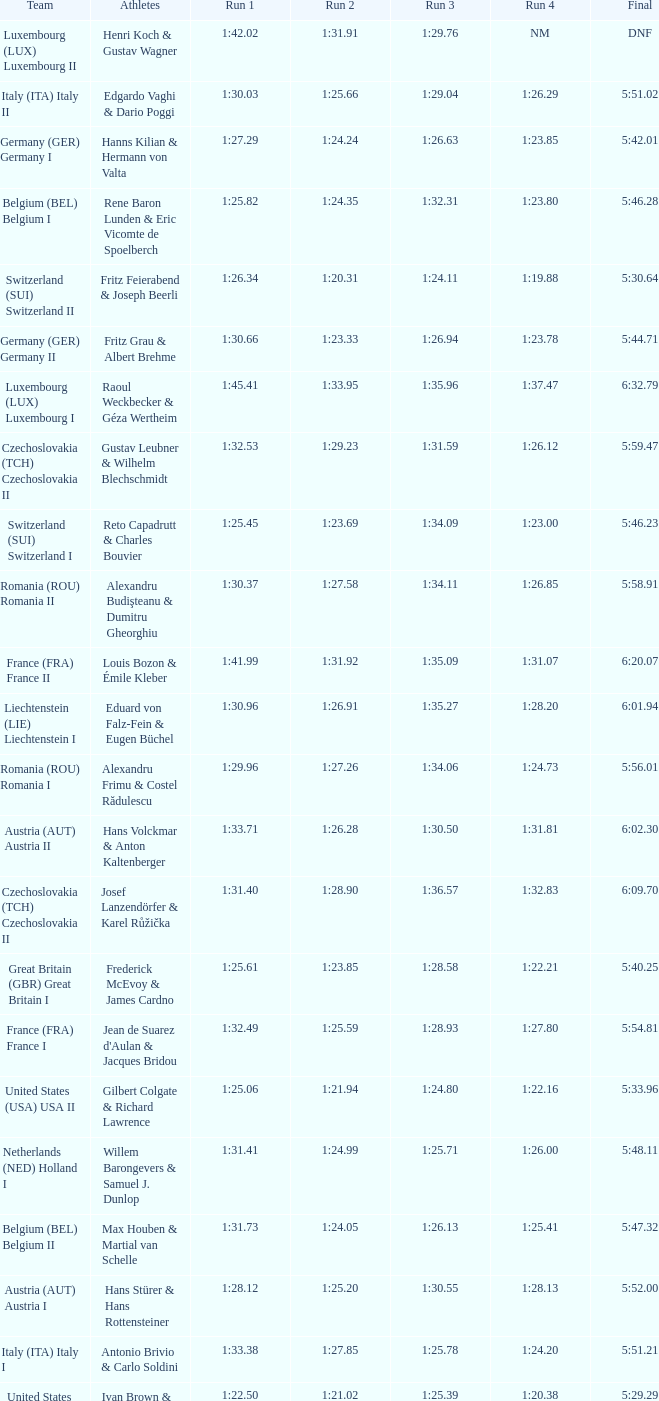Which Run 4 has a Run 3 of 1:26.63? 1:23.85. Write the full table. {'header': ['Team', 'Athletes', 'Run 1', 'Run 2', 'Run 3', 'Run 4', 'Final'], 'rows': [['Luxembourg (LUX) Luxembourg II', 'Henri Koch & Gustav Wagner', '1:42.02', '1:31.91', '1:29.76', 'NM', 'DNF'], ['Italy (ITA) Italy II', 'Edgardo Vaghi & Dario Poggi', '1:30.03', '1:25.66', '1:29.04', '1:26.29', '5:51.02'], ['Germany (GER) Germany I', 'Hanns Kilian & Hermann von Valta', '1:27.29', '1:24.24', '1:26.63', '1:23.85', '5:42.01'], ['Belgium (BEL) Belgium I', 'Rene Baron Lunden & Eric Vicomte de Spoelberch', '1:25.82', '1:24.35', '1:32.31', '1:23.80', '5:46.28'], ['Switzerland (SUI) Switzerland II', 'Fritz Feierabend & Joseph Beerli', '1:26.34', '1:20.31', '1:24.11', '1:19.88', '5:30.64'], ['Germany (GER) Germany II', 'Fritz Grau & Albert Brehme', '1:30.66', '1:23.33', '1:26.94', '1:23.78', '5:44.71'], ['Luxembourg (LUX) Luxembourg I', 'Raoul Weckbecker & Géza Wertheim', '1:45.41', '1:33.95', '1:35.96', '1:37.47', '6:32.79'], ['Czechoslovakia (TCH) Czechoslovakia II', 'Gustav Leubner & Wilhelm Blechschmidt', '1:32.53', '1:29.23', '1:31.59', '1:26.12', '5:59.47'], ['Switzerland (SUI) Switzerland I', 'Reto Capadrutt & Charles Bouvier', '1:25.45', '1:23.69', '1:34.09', '1:23.00', '5:46.23'], ['Romania (ROU) Romania II', 'Alexandru Budişteanu & Dumitru Gheorghiu', '1:30.37', '1:27.58', '1:34.11', '1:26.85', '5:58.91'], ['France (FRA) France II', 'Louis Bozon & Émile Kleber', '1:41.99', '1:31.92', '1:35.09', '1:31.07', '6:20.07'], ['Liechtenstein (LIE) Liechtenstein I', 'Eduard von Falz-Fein & Eugen Büchel', '1:30.96', '1:26.91', '1:35.27', '1:28.20', '6:01.94'], ['Romania (ROU) Romania I', 'Alexandru Frimu & Costel Rădulescu', '1:29.96', '1:27.26', '1:34.06', '1:24.73', '5:56.01'], ['Austria (AUT) Austria II', 'Hans Volckmar & Anton Kaltenberger', '1:33.71', '1:26.28', '1:30.50', '1:31.81', '6:02.30'], ['Czechoslovakia (TCH) Czechoslovakia II', 'Josef Lanzendörfer & Karel Růžička', '1:31.40', '1:28.90', '1:36.57', '1:32.83', '6:09.70'], ['Great Britain (GBR) Great Britain I', 'Frederick McEvoy & James Cardno', '1:25.61', '1:23.85', '1:28.58', '1:22.21', '5:40.25'], ['France (FRA) France I', "Jean de Suarez d'Aulan & Jacques Bridou", '1:32.49', '1:25.59', '1:28.93', '1:27.80', '5:54.81'], ['United States (USA) USA II', 'Gilbert Colgate & Richard Lawrence', '1:25.06', '1:21.94', '1:24.80', '1:22.16', '5:33.96'], ['Netherlands (NED) Holland I', 'Willem Barongevers & Samuel J. Dunlop', '1:31.41', '1:24.99', '1:25.71', '1:26.00', '5:48.11'], ['Belgium (BEL) Belgium II', 'Max Houben & Martial van Schelle', '1:31.73', '1:24.05', '1:26.13', '1:25.41', '5:47.32'], ['Austria (AUT) Austria I', 'Hans Stürer & Hans Rottensteiner', '1:28.12', '1:25.20', '1:30.55', '1:28.13', '5:52.00'], ['Italy (ITA) Italy I', 'Antonio Brivio & Carlo Soldini', '1:33.38', '1:27.85', '1:25.78', '1:24.20', '5:51.21'], ['United States (USA) USA I', 'Ivan Brown & Alan Washbond', '1:22.50', '1:21.02', '1:25.39', '1:20.38', '5:29.29']]} 